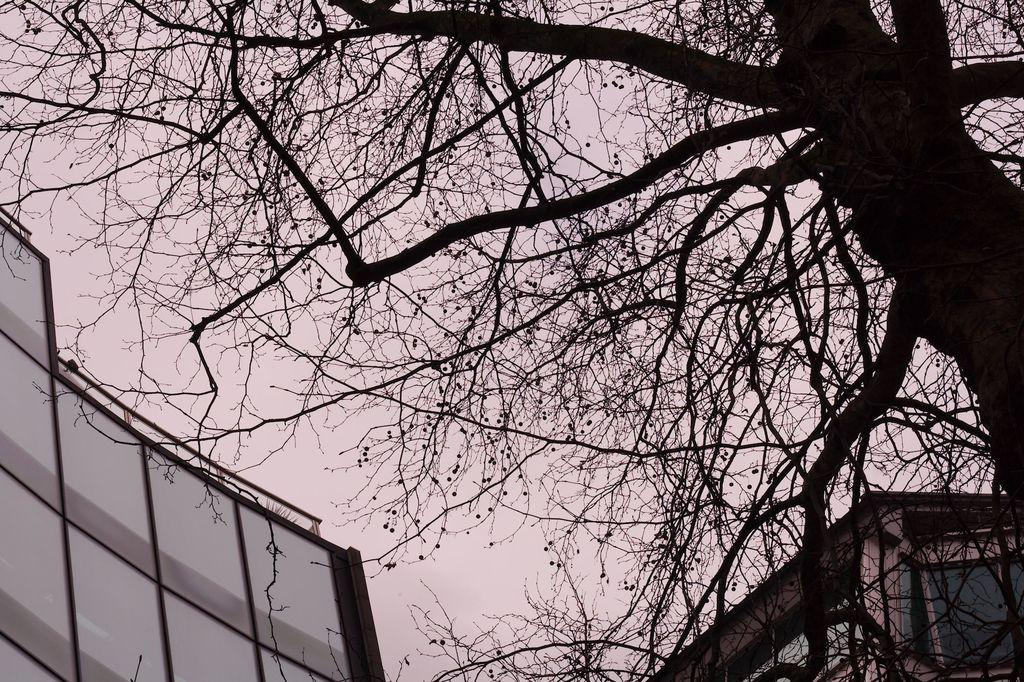What type of structures can be seen in the image? There are buildings in the image. What natural element is present in the image? There is a tree in the image. What is visible in the background of the image? The sky is visible in the image. What type of pancake is being used to decorate the tree in the image? There is no pancake present in the image, and the tree is not being decorated. 